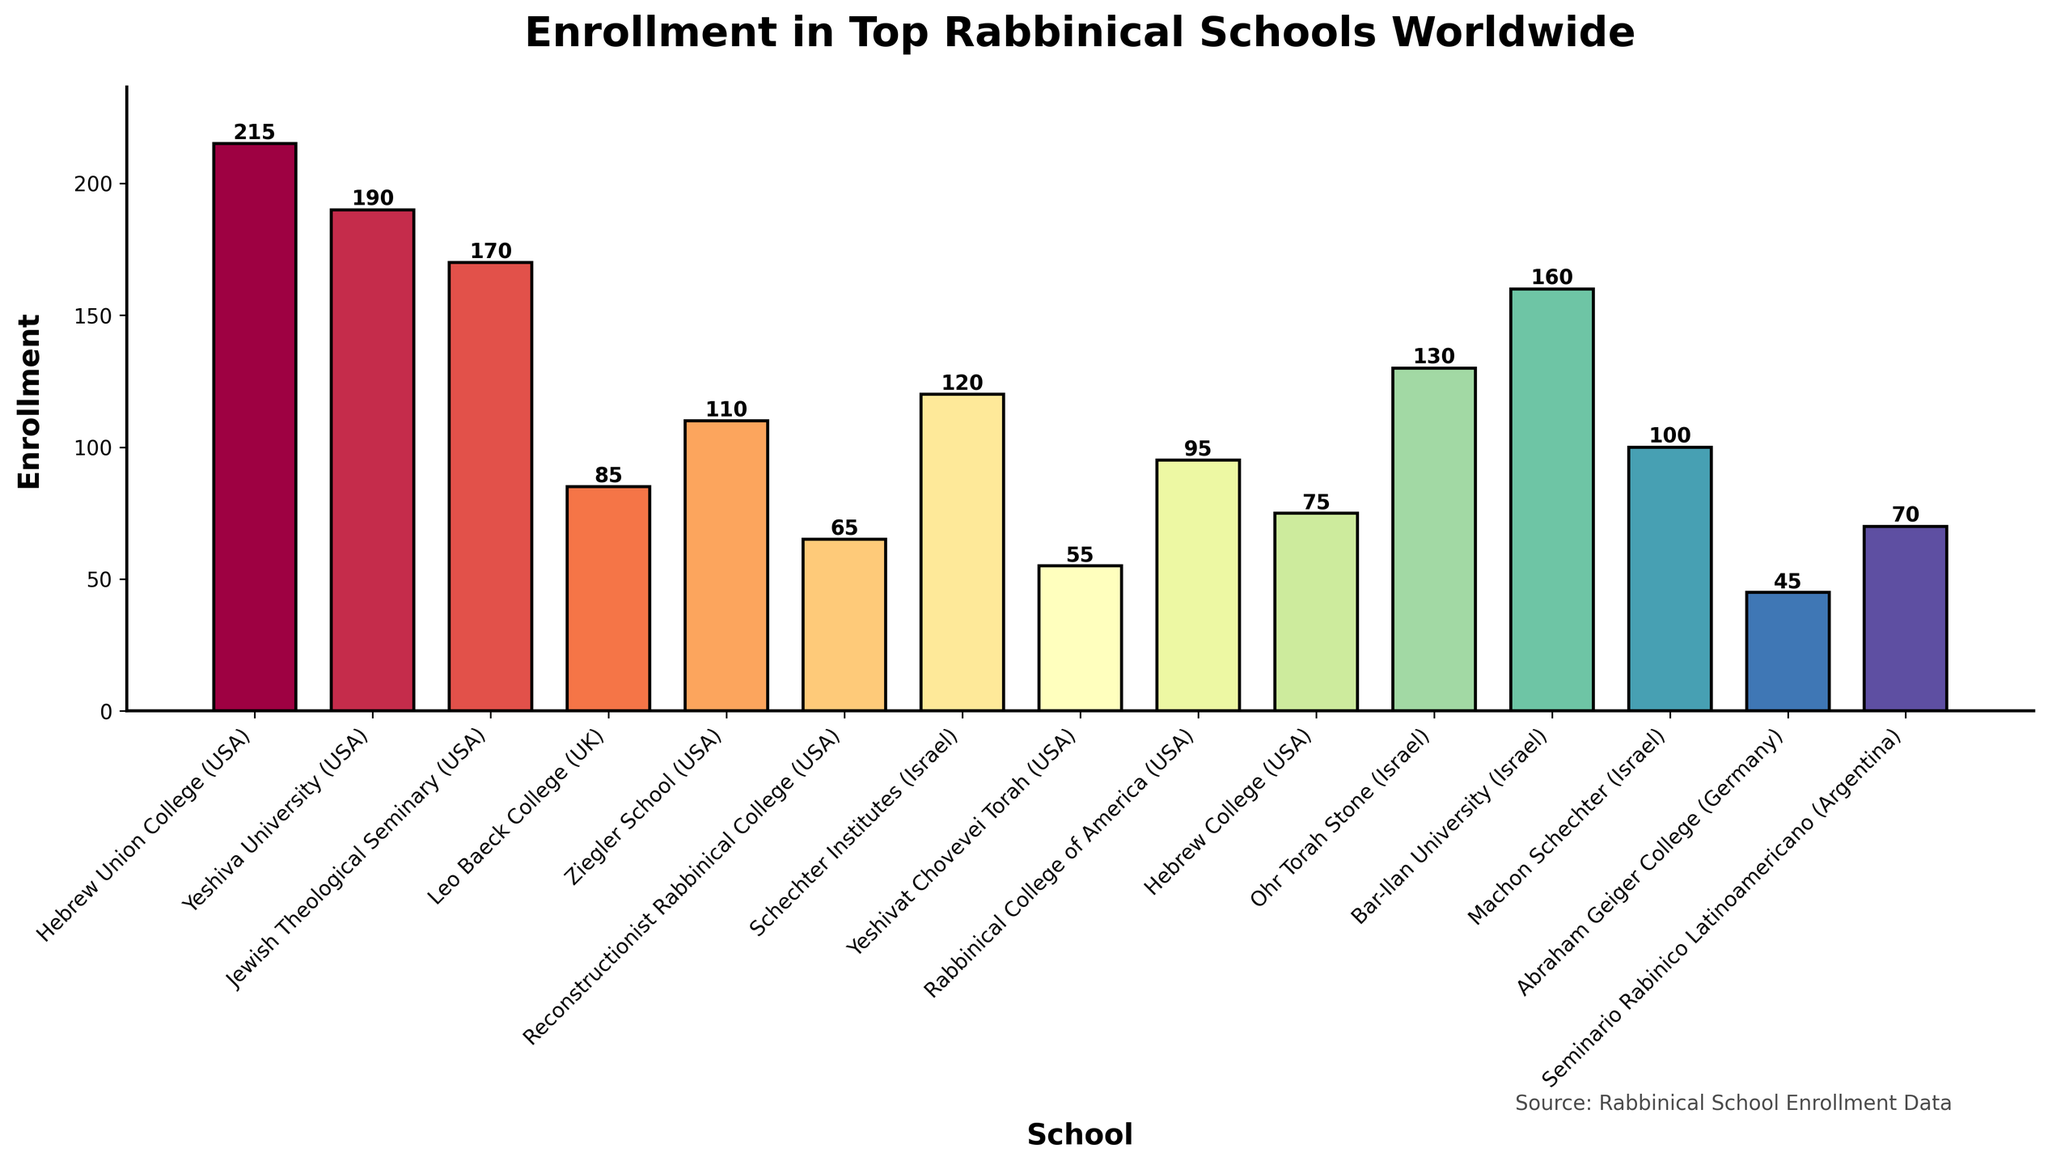Which school has the highest enrollment? Observe the height of the bars to identify the tallest one. Hebrew Union College (USA) has the tallest bar, indicating the highest enrollment.
Answer: Hebrew Union College (USA) Which school has the lowest enrollment? Look for the shortest bar on the chart, which represents the school with the lowest enrollment. Abraham Geiger College (Germany) has the shortest bar.
Answer: Abraham Geiger College (Germany) What is the combined enrollment for the Israel-based schools? Summing up the enrollments for Schechter Institutes, Ohr Torah Stone, Bar-Ilan University, and Machon Schechter (120 + 130 + 160 + 100). The combined enrollment is 510.
Answer: 510 How does the enrollment at Yeshiva University (USA) compare to Hebrew College (USA)? Identify and compare the heights of the bars for Yeshiva University (190) and Hebrew College (75). Yeshiva University has higher enrollment than Hebrew College.
Answer: Yeshiva University (USA) has higher enrollment Which school has a slightly higher enrollment, Jewish Theological Seminary (USA) or Bar-Ilan University (Israel)? Compare the heights of the bars for Jewish Theological Seminary (170) and Bar-Ilan University (160). The Jewish Theological Seminary has a slightly higher enrollment.
Answer: Jewish Theological Seminary (USA) What is the difference in enrollment between the highest and lowest enrolled schools? Identify the highest enrolment (Hebrew Union College, 215) and the lowest (Abraham Geiger College, 45). Subtract the lowest from the highest (215 - 45). The difference is 170.
Answer: 170 If you averaged the enrollments of the US-based schools only, what would it be? Add the enrollments of the US-based schools (215 + 190 + 170 + 110 + 65 + 55 + 95 + 75) and then divide by the number of US-based schools (8). The sum is 975, and the average is 975 / 8 = 121.875.
Answer: 121.875 Which school's bar is colored differently compared to others in its group (country of origin)? Each school's bar is uniquely colored without any group-specific color coding; each has a distinct gradient color, so there is no visual differentiation based on country.
Answer: None 